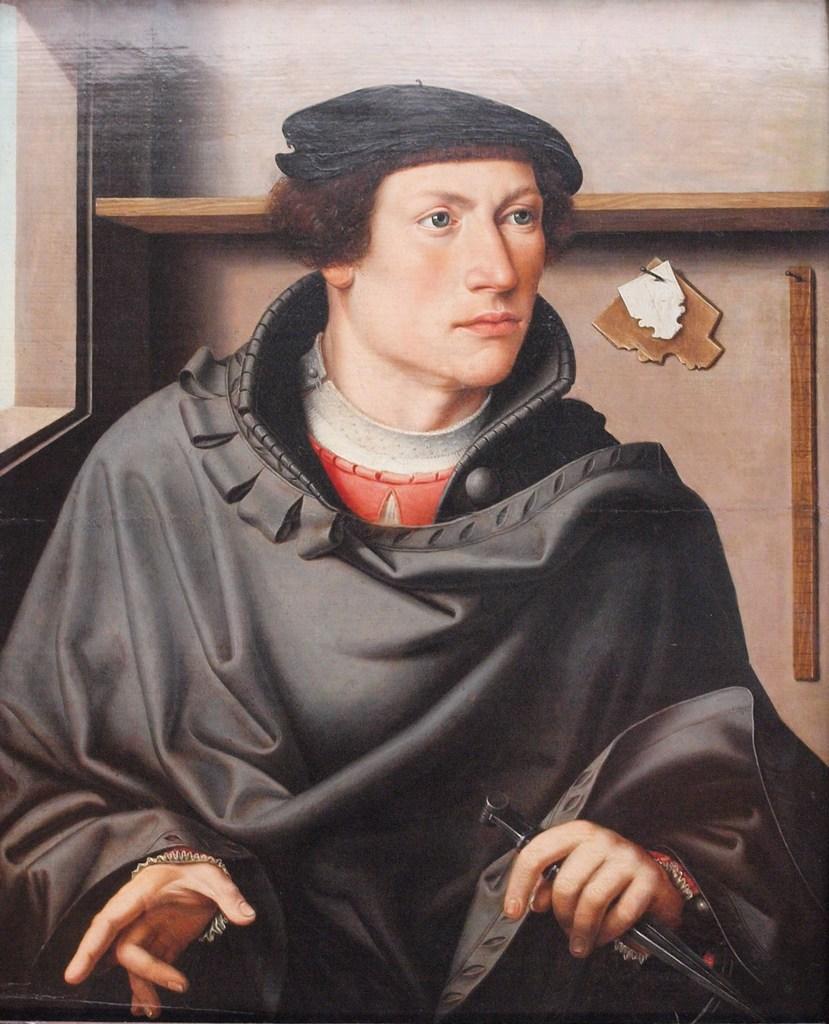How would you summarize this image in a sentence or two? This image looks like a painting. In this image there is a man wearing black coat is sitting. In the background, there is a wall and a rack made up of wood. 